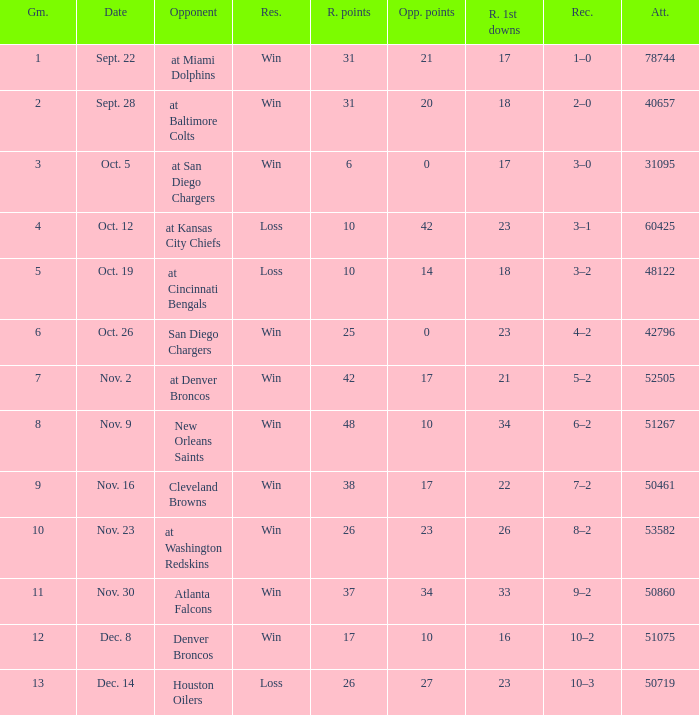What was the result of the game seen by 31095 people? Win. 